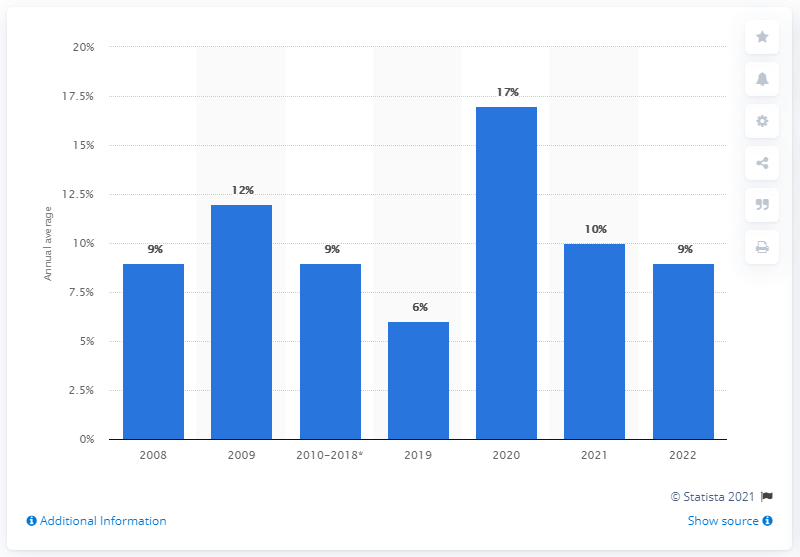Outline some significant characteristics in this image. The forecast for the average annual household savings ratio to jump to in 2020 is 17%. 